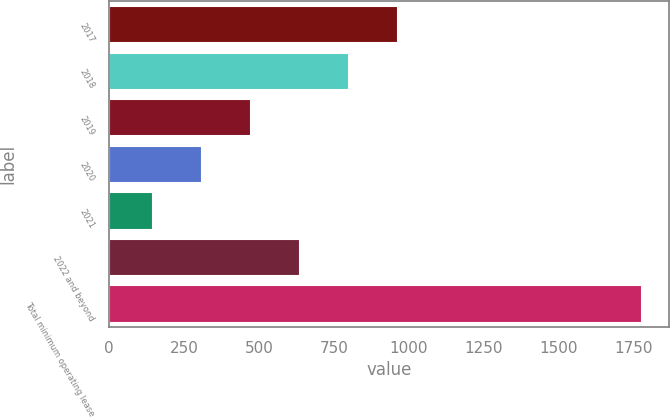<chart> <loc_0><loc_0><loc_500><loc_500><bar_chart><fcel>2017<fcel>2018<fcel>2019<fcel>2020<fcel>2021<fcel>2022 and beyond<fcel>Total minimum operating lease<nl><fcel>963.5<fcel>800.2<fcel>473.6<fcel>310.3<fcel>147<fcel>636.9<fcel>1780<nl></chart> 